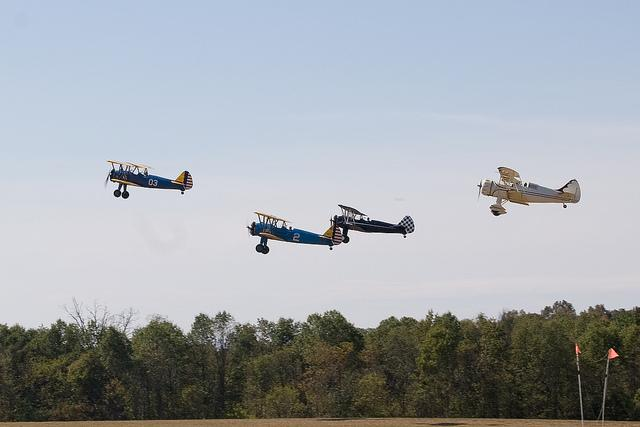What type of activities are happening here?

Choices:
A) winter
B) electronic
C) aquatic
D) aviation aviation 